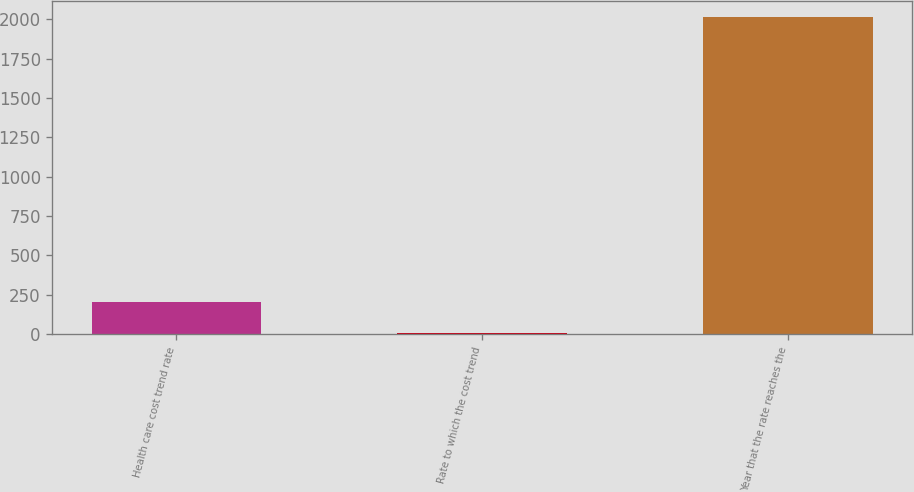Convert chart to OTSL. <chart><loc_0><loc_0><loc_500><loc_500><bar_chart><fcel>Health care cost trend rate<fcel>Rate to which the cost trend<fcel>Year that the rate reaches the<nl><fcel>206<fcel>5<fcel>2015<nl></chart> 